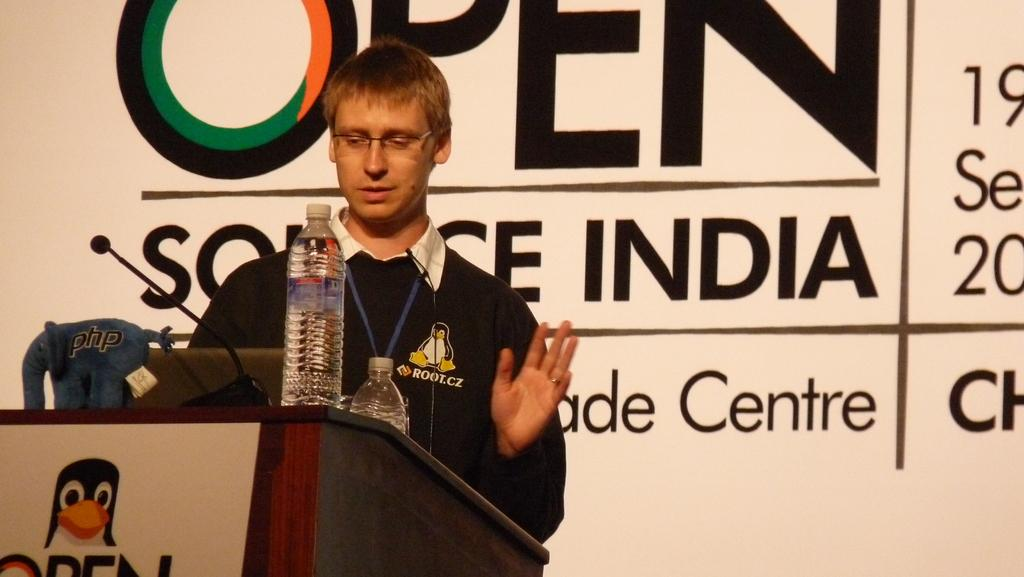<image>
Summarize the visual content of the image. A sign behind a man speaking has the word open on it. 